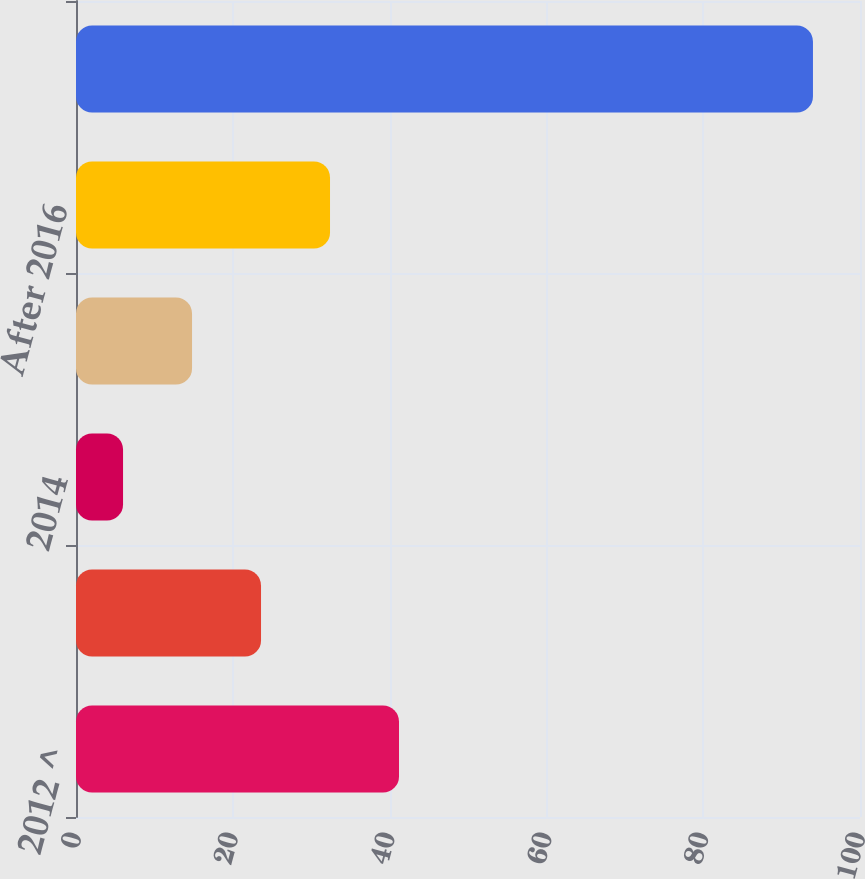Convert chart to OTSL. <chart><loc_0><loc_0><loc_500><loc_500><bar_chart><fcel>2012 ^<fcel>2013<fcel>2014<fcel>2016<fcel>After 2016<fcel>Total minimum lease payments<nl><fcel>41.2<fcel>23.6<fcel>6<fcel>14.8<fcel>32.4<fcel>94<nl></chart> 